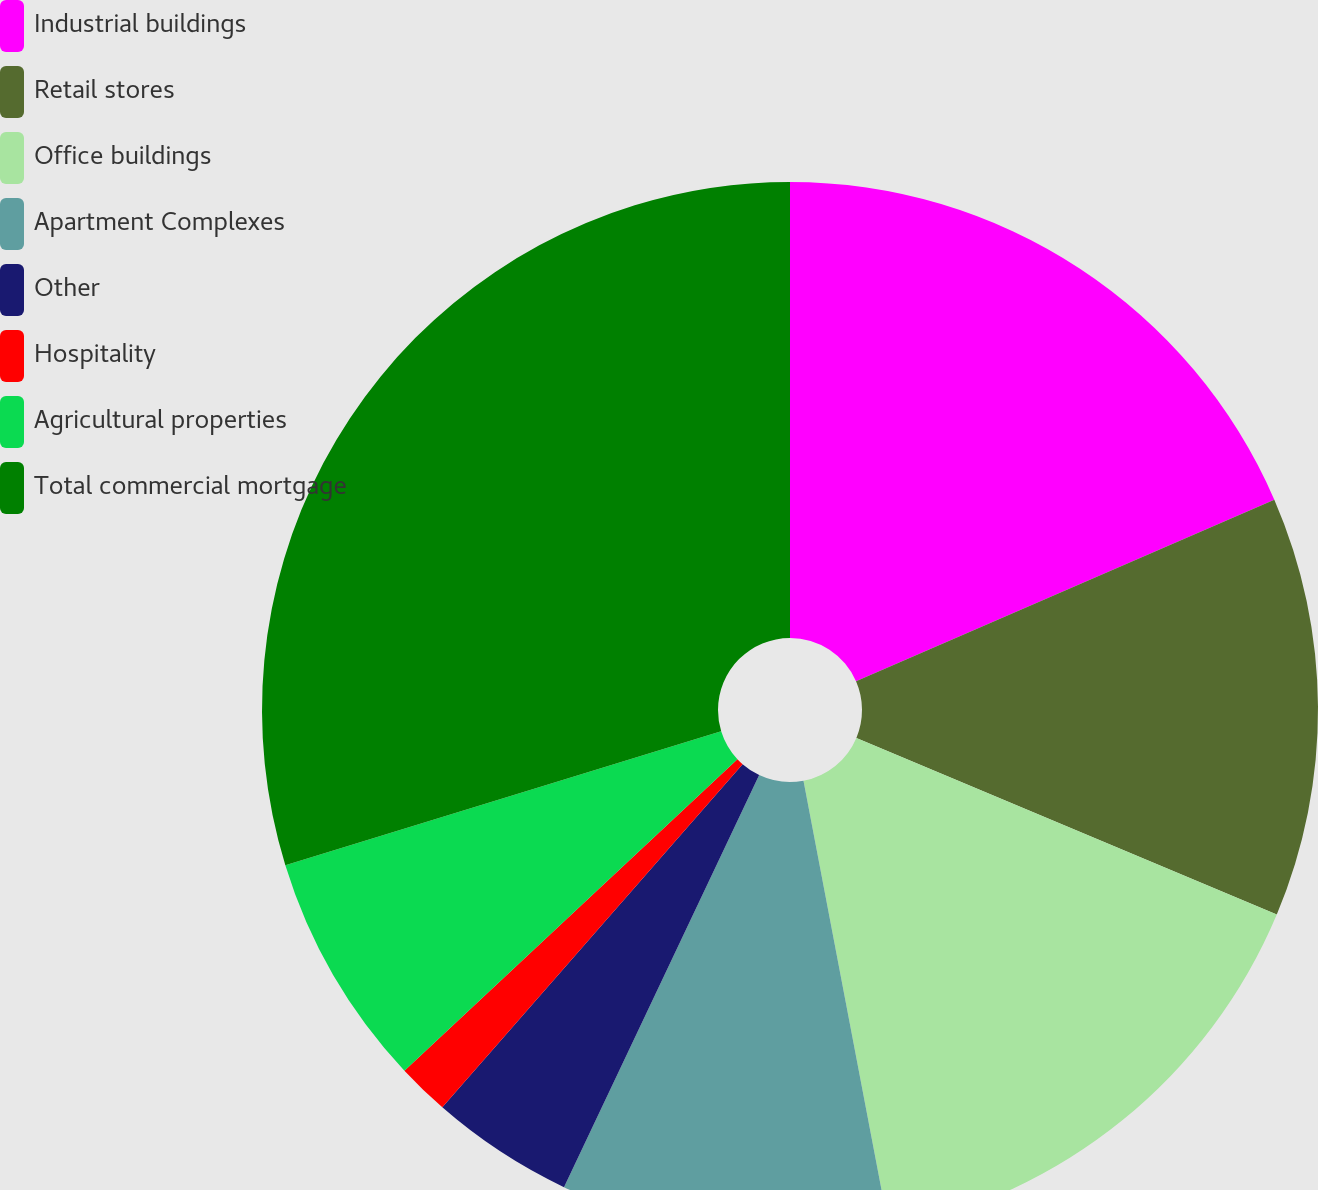Convert chart. <chart><loc_0><loc_0><loc_500><loc_500><pie_chart><fcel>Industrial buildings<fcel>Retail stores<fcel>Office buildings<fcel>Apartment Complexes<fcel>Other<fcel>Hospitality<fcel>Agricultural properties<fcel>Total commercial mortgage<nl><fcel>18.48%<fcel>12.85%<fcel>15.67%<fcel>10.04%<fcel>4.4%<fcel>1.59%<fcel>7.22%<fcel>29.75%<nl></chart> 